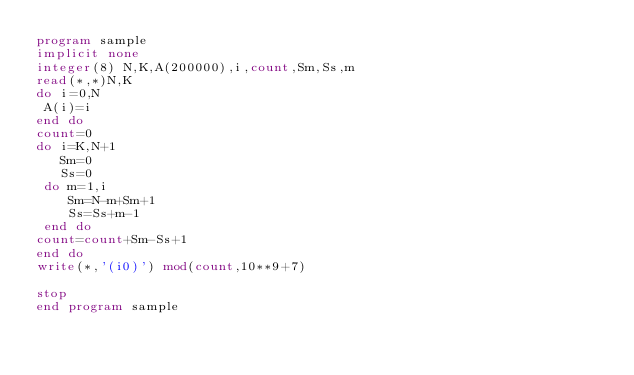<code> <loc_0><loc_0><loc_500><loc_500><_FORTRAN_>program sample
implicit none
integer(8) N,K,A(200000),i,count,Sm,Ss,m
read(*,*)N,K
do i=0,N
 A(i)=i
end do
count=0
do i=K,N+1
   Sm=0
   Ss=0
 do m=1,i
    Sm=N-m+Sm+1
    Ss=Ss+m-1
 end do
count=count+Sm-Ss+1
end do
write(*,'(i0)') mod(count,10**9+7)

stop
end program sample</code> 